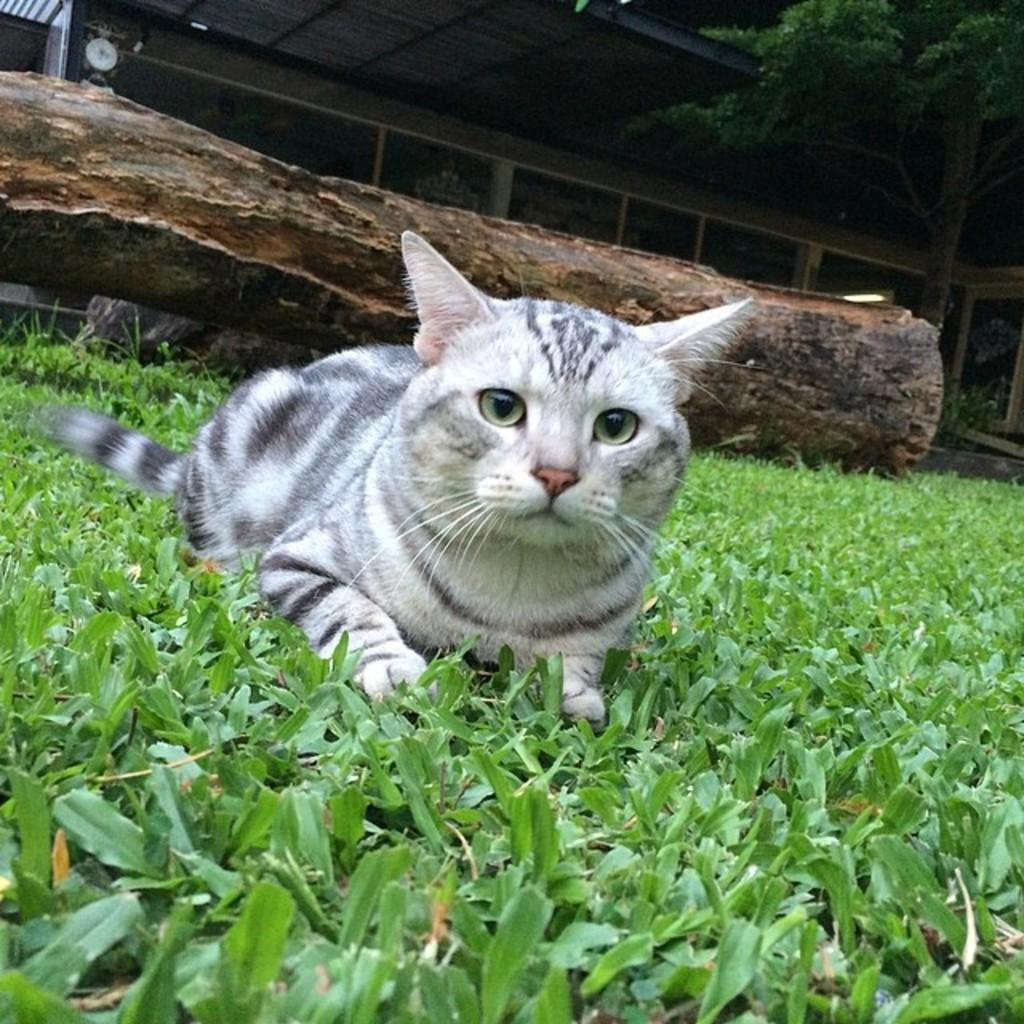What is the main subject in the center of the image? There is a cat in the center of the image. Where is the cat located? The cat is on the grassland. What is behind the cat? There is a log behind the cat. What can be seen in the background of the image? There are windows and trees visible in the image. What is at the top of the image? There is a roof at the top side of the image. What type of song is the cat singing in the image? There is no indication that the cat is singing in the image. Cats do not sing songs like humans do. 